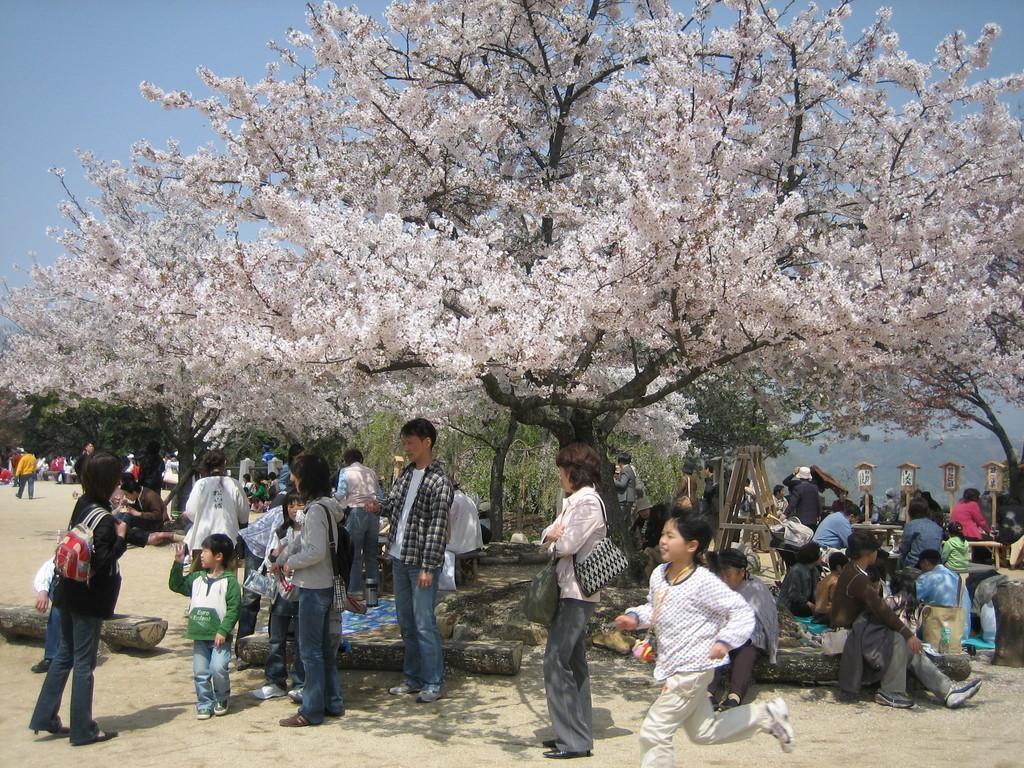How would you summarize this image in a sentence or two? In this picture we can see a group of people and wooden logs on the ground and in the background we can see trees, sky and some objects. 